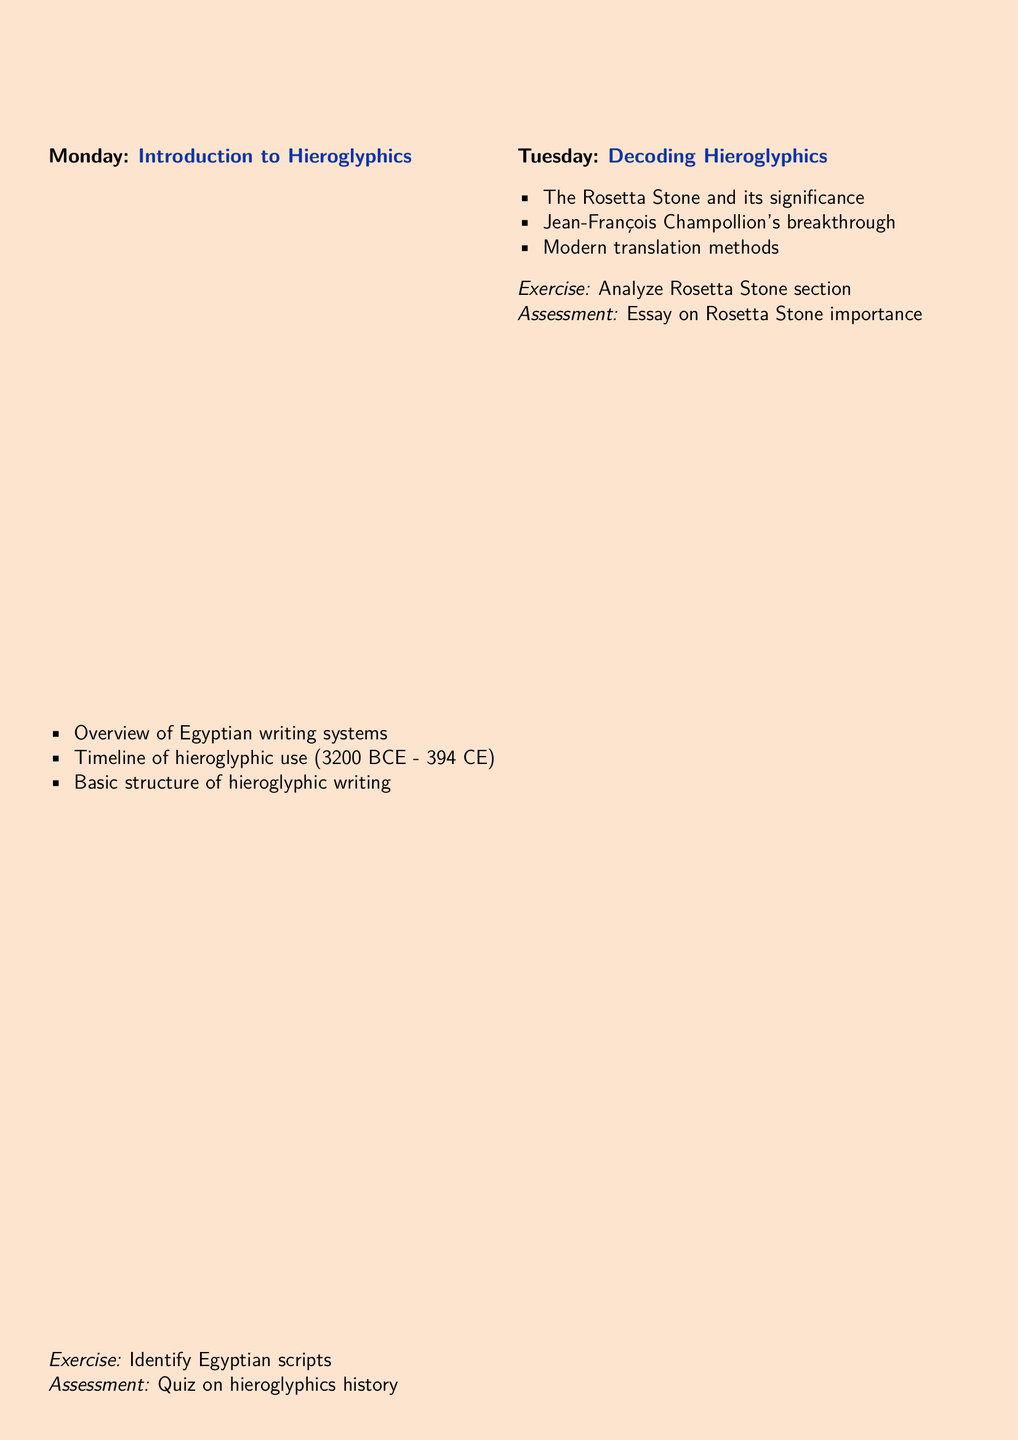What is the topic for Monday? The topic is listed under the day's activities as "Introduction to Hieroglyphics."
Answer: Introduction to Hieroglyphics What significant artifact is discussed on Tuesday? The document mentions "The Rosetta Stone" in the activities for Tuesday.
Answer: The Rosetta Stone How many types of signs are covered on Wednesday? The activities for Wednesday include three types: uniliteral, biliteral, and trilateral signs.
Answer: Three What is the exercise for Thursday? The exercise is indicated as "Translate simple hieroglyphic sentences from the Pyramid Texts."
Answer: Translate simple hieroglyphic sentences from the Pyramid Texts What group project is assigned on Friday? The project is described as "Create a wall panel with hieroglyphic inscriptions explaining a chosen myth or historical event."
Answer: Create a wall panel with hieroglyphic inscriptions explaining a chosen myth or historical event Which two types of resources are listed in the additional resources section? The document mentions books and software as types of resources provided in the list.
Answer: Book and Software How many criteria are used for assessment? The number of criteria is explicitly listed in the assessment criteria section.
Answer: Five Who are the authors of the recommended book? The authors' names are specified in the additional resources section: Mark Collier and Bill Manley.
Answer: Mark Collier and Bill Manley What activity involves designing a cartouche? The exercise related to cartouches is done on Friday under the topic "Hieroglyphics in Art & Architecture."
Answer: Design a personalized cartouche 